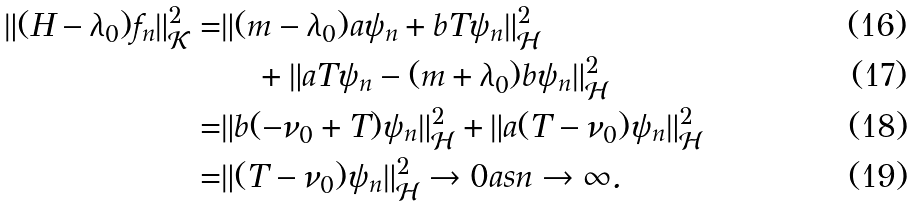Convert formula to latex. <formula><loc_0><loc_0><loc_500><loc_500>\| ( H - \lambda _ { 0 } ) f _ { n } \| _ { \mathcal { K } } ^ { 2 } = & \| ( m - \lambda _ { 0 } ) a \psi _ { n } + b T \psi _ { n } \| _ { \mathcal { H } } ^ { 2 } \\ & \quad + \| a T \psi _ { n } - ( m + \lambda _ { 0 } ) b \psi _ { n } \| _ { \mathcal { H } } ^ { 2 } \\ = & \| b ( - \nu _ { 0 } + T ) \psi _ { n } \| _ { \mathcal { H } } ^ { 2 } + \| a ( T - \nu _ { 0 } ) \psi _ { n } \| _ { \mathcal { H } } ^ { 2 } \\ = & \| ( T - \nu _ { 0 } ) \psi _ { n } \| _ { \mathcal { H } } ^ { 2 } \to 0 a s n \to \infty .</formula> 